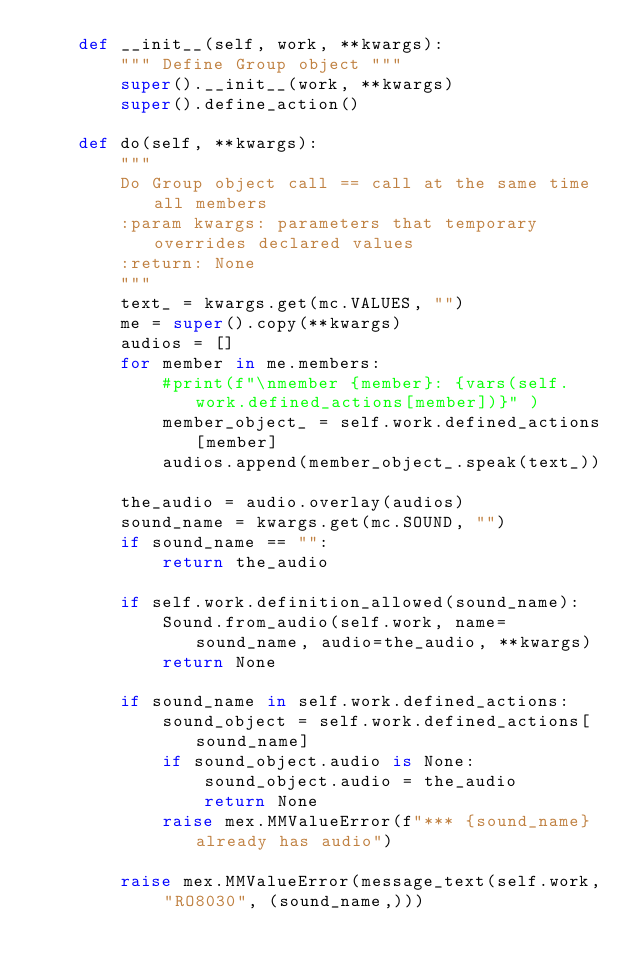Convert code to text. <code><loc_0><loc_0><loc_500><loc_500><_Python_>    def __init__(self, work, **kwargs):
        """ Define Group object """
        super().__init__(work, **kwargs)
        super().define_action()

    def do(self, **kwargs):
        """
        Do Group object call == call at the same time all members
        :param kwargs: parameters that temporary overrides declared values
        :return: None
        """
        text_ = kwargs.get(mc.VALUES, "")
        me = super().copy(**kwargs)
        audios = []
        for member in me.members:
            #print(f"\nmember {member}: {vars(self.work.defined_actions[member])}" )
            member_object_ = self.work.defined_actions[member]
            audios.append(member_object_.speak(text_))

        the_audio = audio.overlay(audios)
        sound_name = kwargs.get(mc.SOUND, "")
        if sound_name == "":
            return the_audio

        if self.work.definition_allowed(sound_name):
            Sound.from_audio(self.work, name=sound_name, audio=the_audio, **kwargs)
            return None

        if sound_name in self.work.defined_actions:
            sound_object = self.work.defined_actions[sound_name]
            if sound_object.audio is None:
                sound_object.audio = the_audio
                return None
            raise mex.MMValueError(f"*** {sound_name} already has audio")

        raise mex.MMValueError(message_text(self.work, "RO8030", (sound_name,)))
</code> 